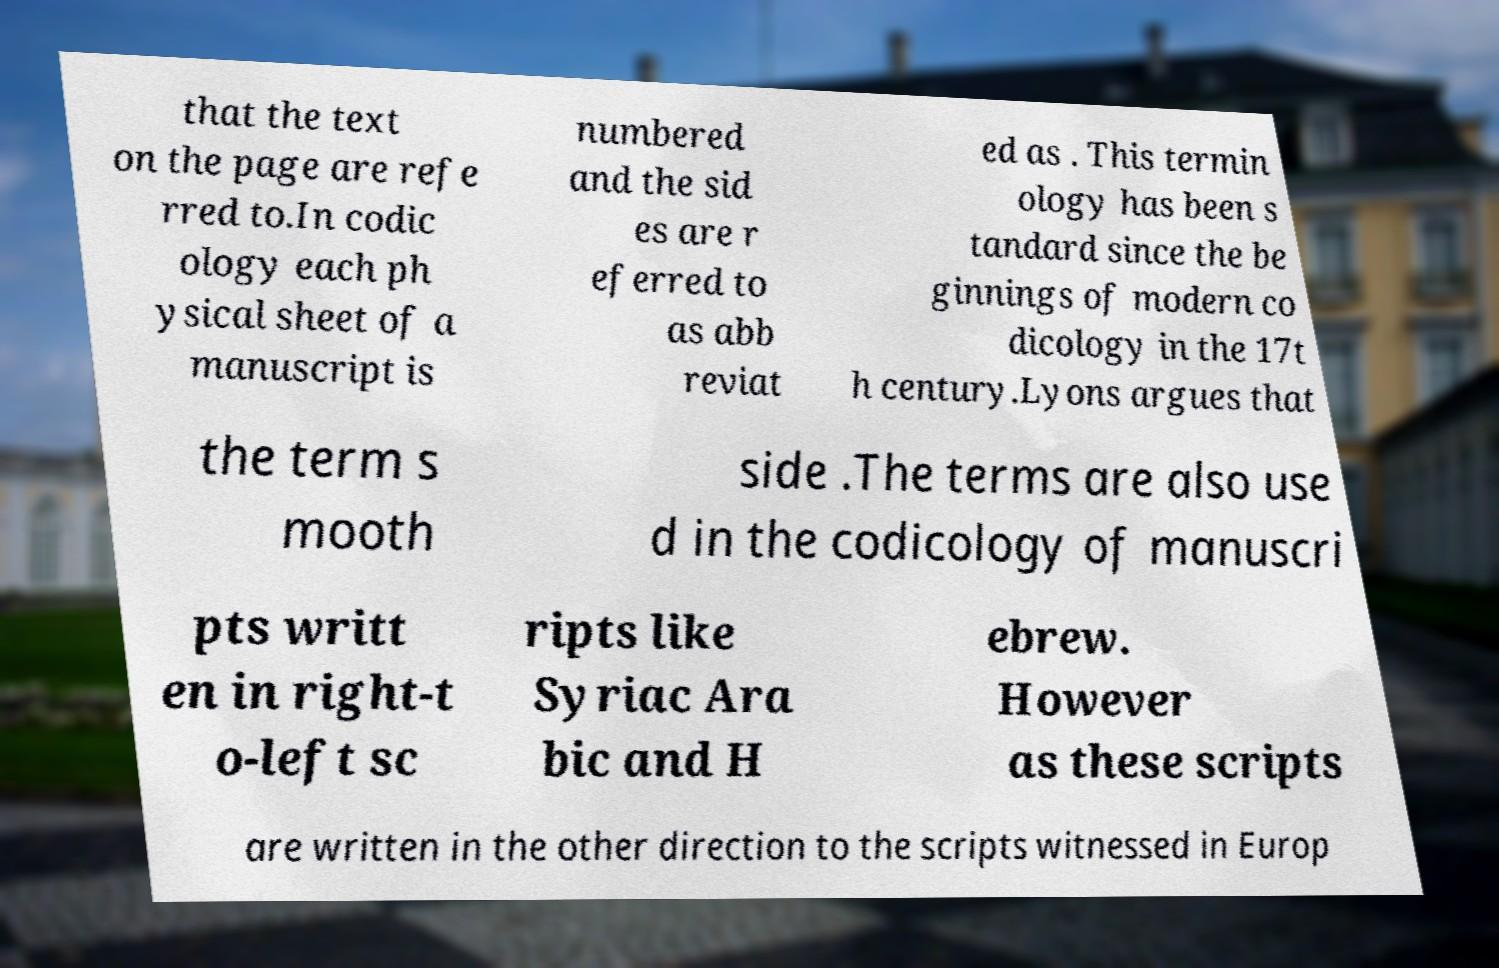Could you extract and type out the text from this image? that the text on the page are refe rred to.In codic ology each ph ysical sheet of a manuscript is numbered and the sid es are r eferred to as abb reviat ed as . This termin ology has been s tandard since the be ginnings of modern co dicology in the 17t h century.Lyons argues that the term s mooth side .The terms are also use d in the codicology of manuscri pts writt en in right-t o-left sc ripts like Syriac Ara bic and H ebrew. However as these scripts are written in the other direction to the scripts witnessed in Europ 